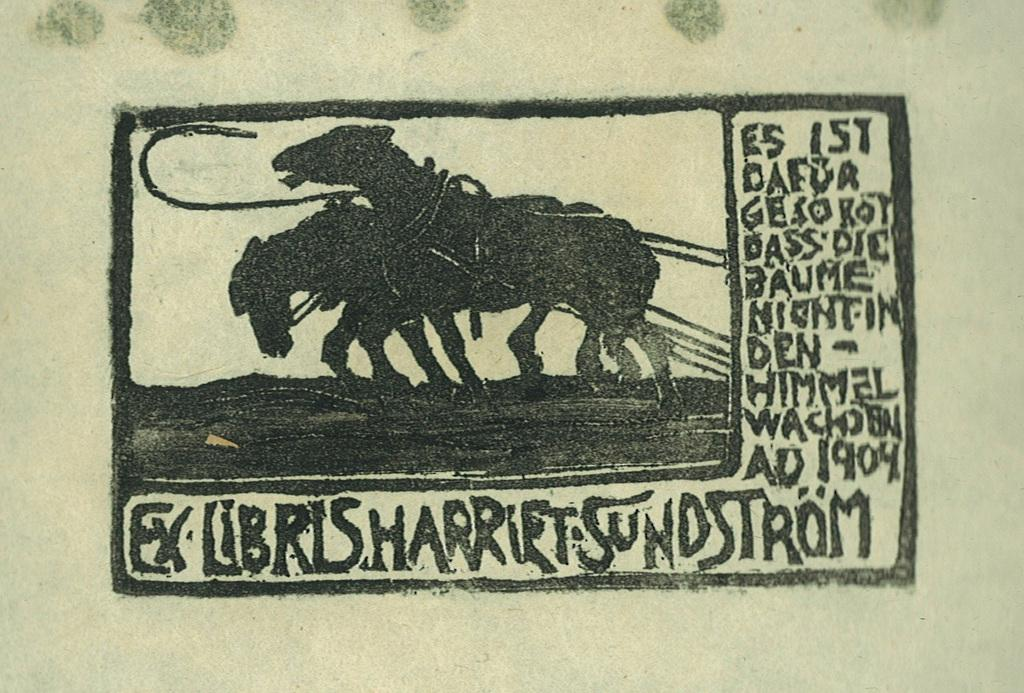What is depicted in the image? There is a sketch of horses in the image. What else can be found on the image besides the sketch of horses? There is text written on the image. What type of cookware is shown in the image? There is no cookware present in the image; it features a sketch of horses and text. What memory is being depicted in the image? The image does not depict a memory; it is a sketch of horses with text. 